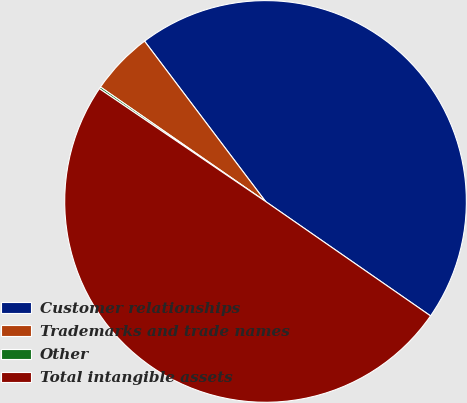Convert chart to OTSL. <chart><loc_0><loc_0><loc_500><loc_500><pie_chart><fcel>Customer relationships<fcel>Trademarks and trade names<fcel>Other<fcel>Total intangible assets<nl><fcel>44.94%<fcel>5.06%<fcel>0.16%<fcel>49.84%<nl></chart> 